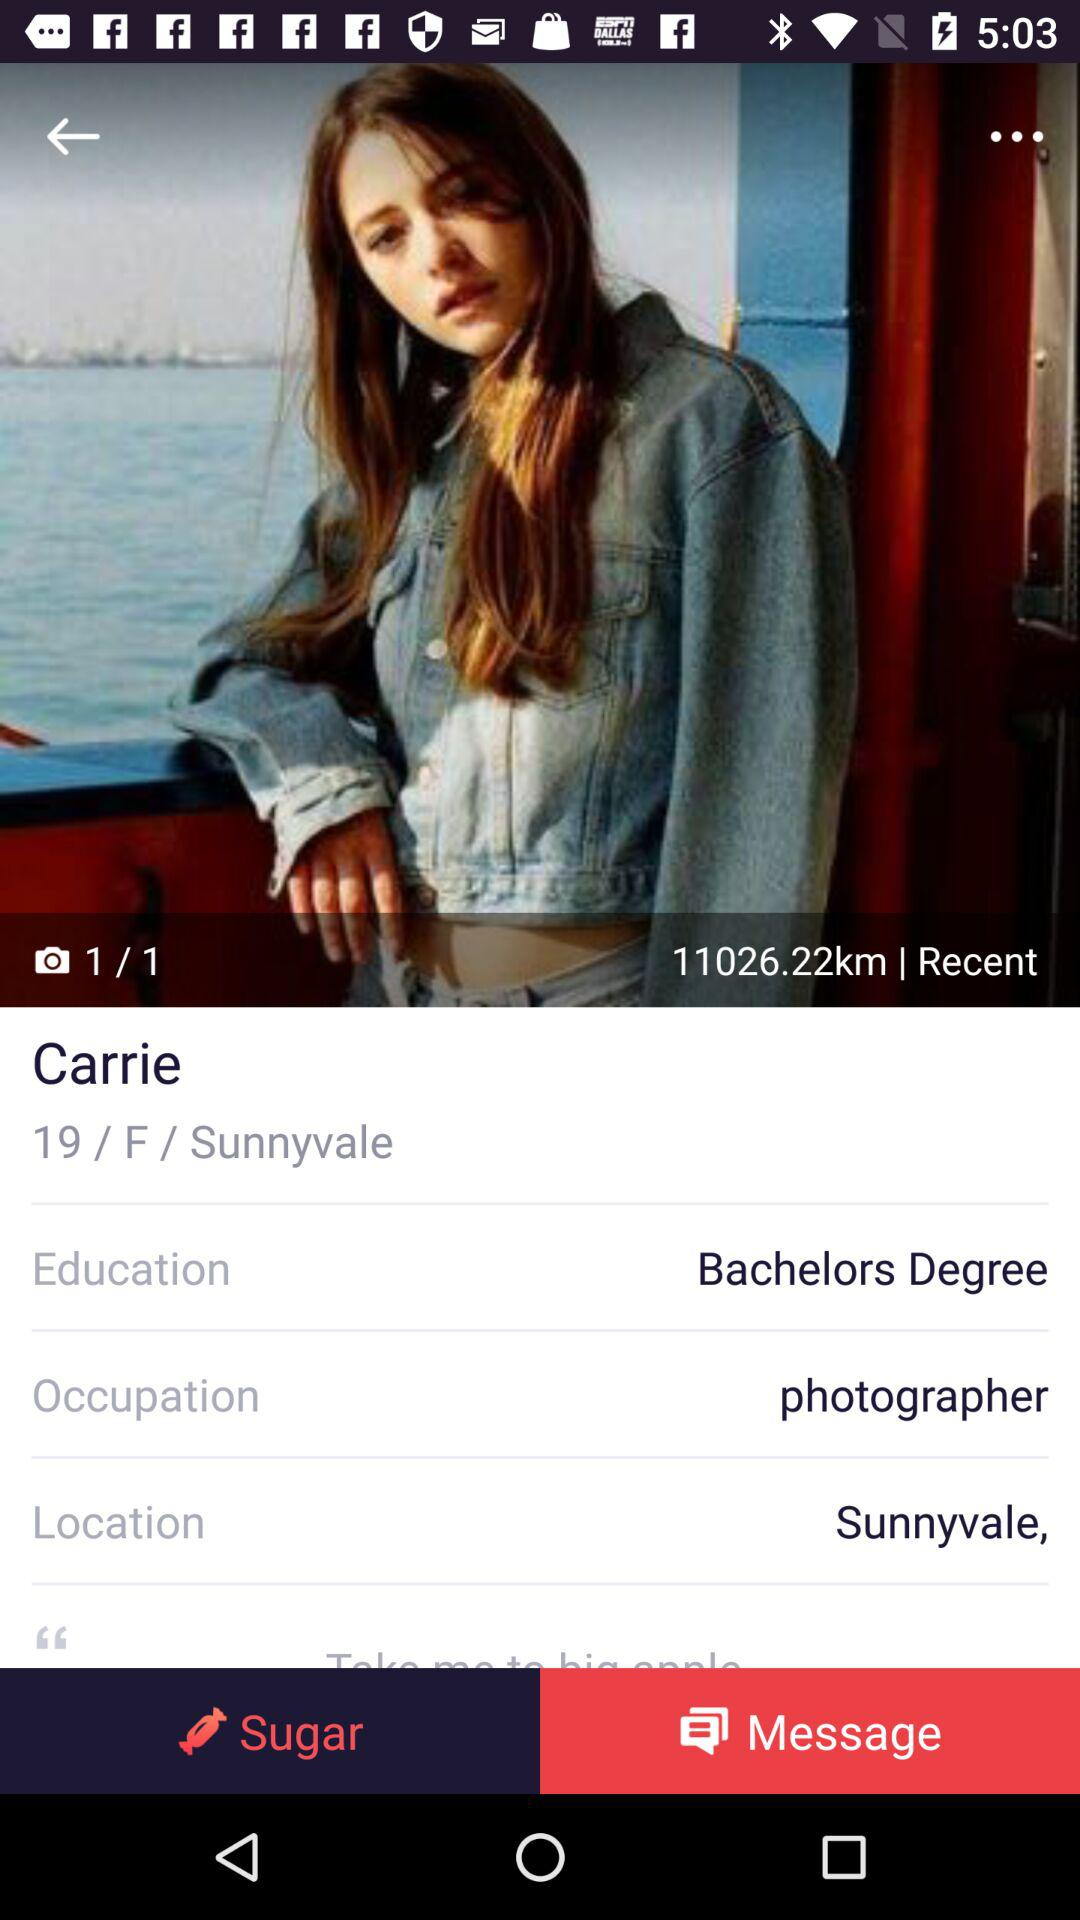What is the occupation of the person in the photo?
Answer the question using a single word or phrase. Photographer 